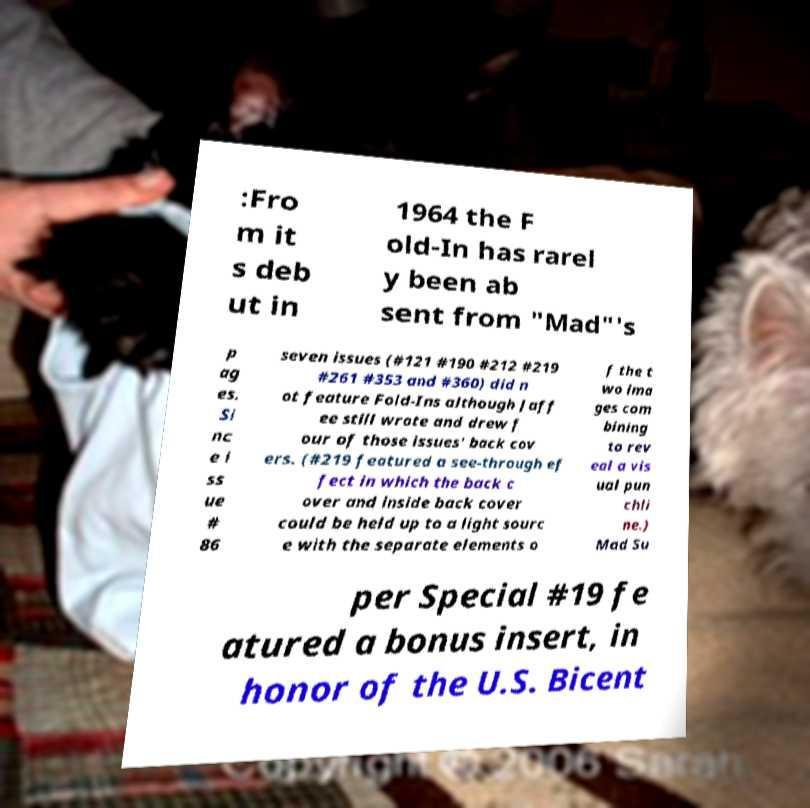Please read and relay the text visible in this image. What does it say? :Fro m it s deb ut in 1964 the F old-In has rarel y been ab sent from "Mad"'s p ag es. Si nc e i ss ue # 86 seven issues (#121 #190 #212 #219 #261 #353 and #360) did n ot feature Fold-Ins although Jaff ee still wrote and drew f our of those issues' back cov ers. (#219 featured a see-through ef fect in which the back c over and inside back cover could be held up to a light sourc e with the separate elements o f the t wo ima ges com bining to rev eal a vis ual pun chli ne.) Mad Su per Special #19 fe atured a bonus insert, in honor of the U.S. Bicent 